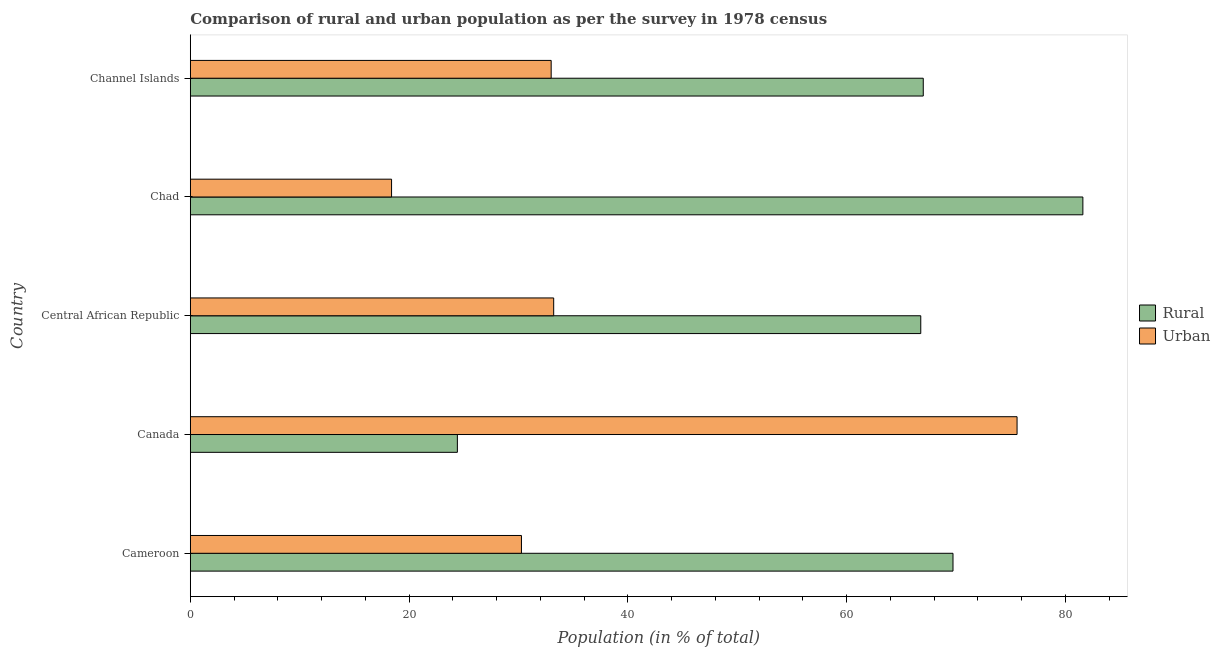Are the number of bars per tick equal to the number of legend labels?
Your response must be concise. Yes. How many bars are there on the 4th tick from the top?
Keep it short and to the point. 2. How many bars are there on the 4th tick from the bottom?
Your answer should be compact. 2. What is the label of the 2nd group of bars from the top?
Keep it short and to the point. Chad. In how many cases, is the number of bars for a given country not equal to the number of legend labels?
Offer a terse response. 0. What is the rural population in Chad?
Give a very brief answer. 81.6. Across all countries, what is the maximum urban population?
Keep it short and to the point. 75.58. In which country was the rural population minimum?
Your answer should be very brief. Canada. What is the total urban population in the graph?
Keep it short and to the point. 190.47. What is the difference between the urban population in Cameroon and that in Channel Islands?
Give a very brief answer. -2.72. What is the difference between the urban population in Cameroon and the rural population in Canada?
Give a very brief answer. 5.86. What is the average rural population per country?
Offer a terse response. 61.91. What is the difference between the rural population and urban population in Channel Islands?
Your answer should be very brief. 34.02. What is the ratio of the urban population in Chad to that in Channel Islands?
Make the answer very short. 0.56. What is the difference between the highest and the second highest rural population?
Make the answer very short. 11.87. What is the difference between the highest and the lowest urban population?
Provide a succinct answer. 57.18. In how many countries, is the urban population greater than the average urban population taken over all countries?
Give a very brief answer. 1. What does the 1st bar from the top in Central African Republic represents?
Ensure brevity in your answer.  Urban. What does the 1st bar from the bottom in Central African Republic represents?
Offer a very short reply. Rural. Are all the bars in the graph horizontal?
Provide a succinct answer. Yes. What is the difference between two consecutive major ticks on the X-axis?
Your answer should be compact. 20. Are the values on the major ticks of X-axis written in scientific E-notation?
Offer a very short reply. No. Does the graph contain any zero values?
Offer a very short reply. No. What is the title of the graph?
Keep it short and to the point. Comparison of rural and urban population as per the survey in 1978 census. Does "Central government" appear as one of the legend labels in the graph?
Keep it short and to the point. No. What is the label or title of the X-axis?
Make the answer very short. Population (in % of total). What is the Population (in % of total) in Rural in Cameroon?
Offer a terse response. 69.73. What is the Population (in % of total) in Urban in Cameroon?
Your response must be concise. 30.27. What is the Population (in % of total) of Rural in Canada?
Ensure brevity in your answer.  24.42. What is the Population (in % of total) of Urban in Canada?
Your response must be concise. 75.58. What is the Population (in % of total) of Rural in Central African Republic?
Give a very brief answer. 66.78. What is the Population (in % of total) of Urban in Central African Republic?
Your response must be concise. 33.22. What is the Population (in % of total) in Rural in Chad?
Offer a terse response. 81.6. What is the Population (in % of total) in Rural in Channel Islands?
Keep it short and to the point. 67.01. What is the Population (in % of total) of Urban in Channel Islands?
Your response must be concise. 32.99. Across all countries, what is the maximum Population (in % of total) in Rural?
Make the answer very short. 81.6. Across all countries, what is the maximum Population (in % of total) in Urban?
Your response must be concise. 75.58. Across all countries, what is the minimum Population (in % of total) of Rural?
Provide a succinct answer. 24.42. Across all countries, what is the minimum Population (in % of total) in Urban?
Provide a succinct answer. 18.4. What is the total Population (in % of total) of Rural in the graph?
Make the answer very short. 309.53. What is the total Population (in % of total) of Urban in the graph?
Your response must be concise. 190.47. What is the difference between the Population (in % of total) of Rural in Cameroon and that in Canada?
Offer a very short reply. 45.31. What is the difference between the Population (in % of total) of Urban in Cameroon and that in Canada?
Your response must be concise. -45.31. What is the difference between the Population (in % of total) of Rural in Cameroon and that in Central African Republic?
Offer a very short reply. 2.95. What is the difference between the Population (in % of total) in Urban in Cameroon and that in Central African Republic?
Your response must be concise. -2.95. What is the difference between the Population (in % of total) of Rural in Cameroon and that in Chad?
Your response must be concise. -11.87. What is the difference between the Population (in % of total) of Urban in Cameroon and that in Chad?
Provide a short and direct response. 11.87. What is the difference between the Population (in % of total) of Rural in Cameroon and that in Channel Islands?
Offer a terse response. 2.72. What is the difference between the Population (in % of total) in Urban in Cameroon and that in Channel Islands?
Give a very brief answer. -2.72. What is the difference between the Population (in % of total) in Rural in Canada and that in Central African Republic?
Your response must be concise. -42.36. What is the difference between the Population (in % of total) of Urban in Canada and that in Central African Republic?
Your response must be concise. 42.36. What is the difference between the Population (in % of total) of Rural in Canada and that in Chad?
Your response must be concise. -57.18. What is the difference between the Population (in % of total) in Urban in Canada and that in Chad?
Ensure brevity in your answer.  57.18. What is the difference between the Population (in % of total) of Rural in Canada and that in Channel Islands?
Your response must be concise. -42.59. What is the difference between the Population (in % of total) of Urban in Canada and that in Channel Islands?
Your answer should be compact. 42.59. What is the difference between the Population (in % of total) in Rural in Central African Republic and that in Chad?
Ensure brevity in your answer.  -14.82. What is the difference between the Population (in % of total) of Urban in Central African Republic and that in Chad?
Keep it short and to the point. 14.82. What is the difference between the Population (in % of total) of Rural in Central African Republic and that in Channel Islands?
Your answer should be very brief. -0.23. What is the difference between the Population (in % of total) of Urban in Central African Republic and that in Channel Islands?
Make the answer very short. 0.23. What is the difference between the Population (in % of total) in Rural in Chad and that in Channel Islands?
Your response must be concise. 14.59. What is the difference between the Population (in % of total) of Urban in Chad and that in Channel Islands?
Give a very brief answer. -14.59. What is the difference between the Population (in % of total) of Rural in Cameroon and the Population (in % of total) of Urban in Canada?
Offer a very short reply. -5.86. What is the difference between the Population (in % of total) of Rural in Cameroon and the Population (in % of total) of Urban in Central African Republic?
Make the answer very short. 36.51. What is the difference between the Population (in % of total) of Rural in Cameroon and the Population (in % of total) of Urban in Chad?
Your answer should be very brief. 51.33. What is the difference between the Population (in % of total) in Rural in Cameroon and the Population (in % of total) in Urban in Channel Islands?
Ensure brevity in your answer.  36.73. What is the difference between the Population (in % of total) in Rural in Canada and the Population (in % of total) in Urban in Central African Republic?
Offer a terse response. -8.8. What is the difference between the Population (in % of total) in Rural in Canada and the Population (in % of total) in Urban in Chad?
Provide a succinct answer. 6.02. What is the difference between the Population (in % of total) of Rural in Canada and the Population (in % of total) of Urban in Channel Islands?
Offer a terse response. -8.57. What is the difference between the Population (in % of total) in Rural in Central African Republic and the Population (in % of total) in Urban in Chad?
Your answer should be compact. 48.38. What is the difference between the Population (in % of total) in Rural in Central African Republic and the Population (in % of total) in Urban in Channel Islands?
Your answer should be very brief. 33.79. What is the difference between the Population (in % of total) in Rural in Chad and the Population (in % of total) in Urban in Channel Islands?
Provide a succinct answer. 48.61. What is the average Population (in % of total) of Rural per country?
Your answer should be very brief. 61.91. What is the average Population (in % of total) of Urban per country?
Keep it short and to the point. 38.09. What is the difference between the Population (in % of total) in Rural and Population (in % of total) in Urban in Cameroon?
Offer a very short reply. 39.45. What is the difference between the Population (in % of total) in Rural and Population (in % of total) in Urban in Canada?
Your answer should be very brief. -51.17. What is the difference between the Population (in % of total) in Rural and Population (in % of total) in Urban in Central African Republic?
Ensure brevity in your answer.  33.56. What is the difference between the Population (in % of total) in Rural and Population (in % of total) in Urban in Chad?
Your response must be concise. 63.2. What is the difference between the Population (in % of total) of Rural and Population (in % of total) of Urban in Channel Islands?
Offer a terse response. 34.02. What is the ratio of the Population (in % of total) in Rural in Cameroon to that in Canada?
Provide a short and direct response. 2.86. What is the ratio of the Population (in % of total) in Urban in Cameroon to that in Canada?
Offer a very short reply. 0.4. What is the ratio of the Population (in % of total) in Rural in Cameroon to that in Central African Republic?
Make the answer very short. 1.04. What is the ratio of the Population (in % of total) in Urban in Cameroon to that in Central African Republic?
Your answer should be very brief. 0.91. What is the ratio of the Population (in % of total) in Rural in Cameroon to that in Chad?
Provide a succinct answer. 0.85. What is the ratio of the Population (in % of total) of Urban in Cameroon to that in Chad?
Your answer should be compact. 1.65. What is the ratio of the Population (in % of total) in Rural in Cameroon to that in Channel Islands?
Your answer should be very brief. 1.04. What is the ratio of the Population (in % of total) of Urban in Cameroon to that in Channel Islands?
Ensure brevity in your answer.  0.92. What is the ratio of the Population (in % of total) of Rural in Canada to that in Central African Republic?
Offer a terse response. 0.37. What is the ratio of the Population (in % of total) in Urban in Canada to that in Central African Republic?
Ensure brevity in your answer.  2.28. What is the ratio of the Population (in % of total) in Rural in Canada to that in Chad?
Your response must be concise. 0.3. What is the ratio of the Population (in % of total) in Urban in Canada to that in Chad?
Ensure brevity in your answer.  4.11. What is the ratio of the Population (in % of total) in Rural in Canada to that in Channel Islands?
Provide a short and direct response. 0.36. What is the ratio of the Population (in % of total) of Urban in Canada to that in Channel Islands?
Ensure brevity in your answer.  2.29. What is the ratio of the Population (in % of total) of Rural in Central African Republic to that in Chad?
Provide a short and direct response. 0.82. What is the ratio of the Population (in % of total) in Urban in Central African Republic to that in Chad?
Offer a terse response. 1.81. What is the ratio of the Population (in % of total) of Rural in Central African Republic to that in Channel Islands?
Provide a short and direct response. 1. What is the ratio of the Population (in % of total) of Rural in Chad to that in Channel Islands?
Give a very brief answer. 1.22. What is the ratio of the Population (in % of total) of Urban in Chad to that in Channel Islands?
Keep it short and to the point. 0.56. What is the difference between the highest and the second highest Population (in % of total) of Rural?
Your response must be concise. 11.87. What is the difference between the highest and the second highest Population (in % of total) in Urban?
Provide a short and direct response. 42.36. What is the difference between the highest and the lowest Population (in % of total) of Rural?
Provide a short and direct response. 57.18. What is the difference between the highest and the lowest Population (in % of total) of Urban?
Your answer should be compact. 57.18. 